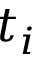Convert formula to latex. <formula><loc_0><loc_0><loc_500><loc_500>t _ { i }</formula> 